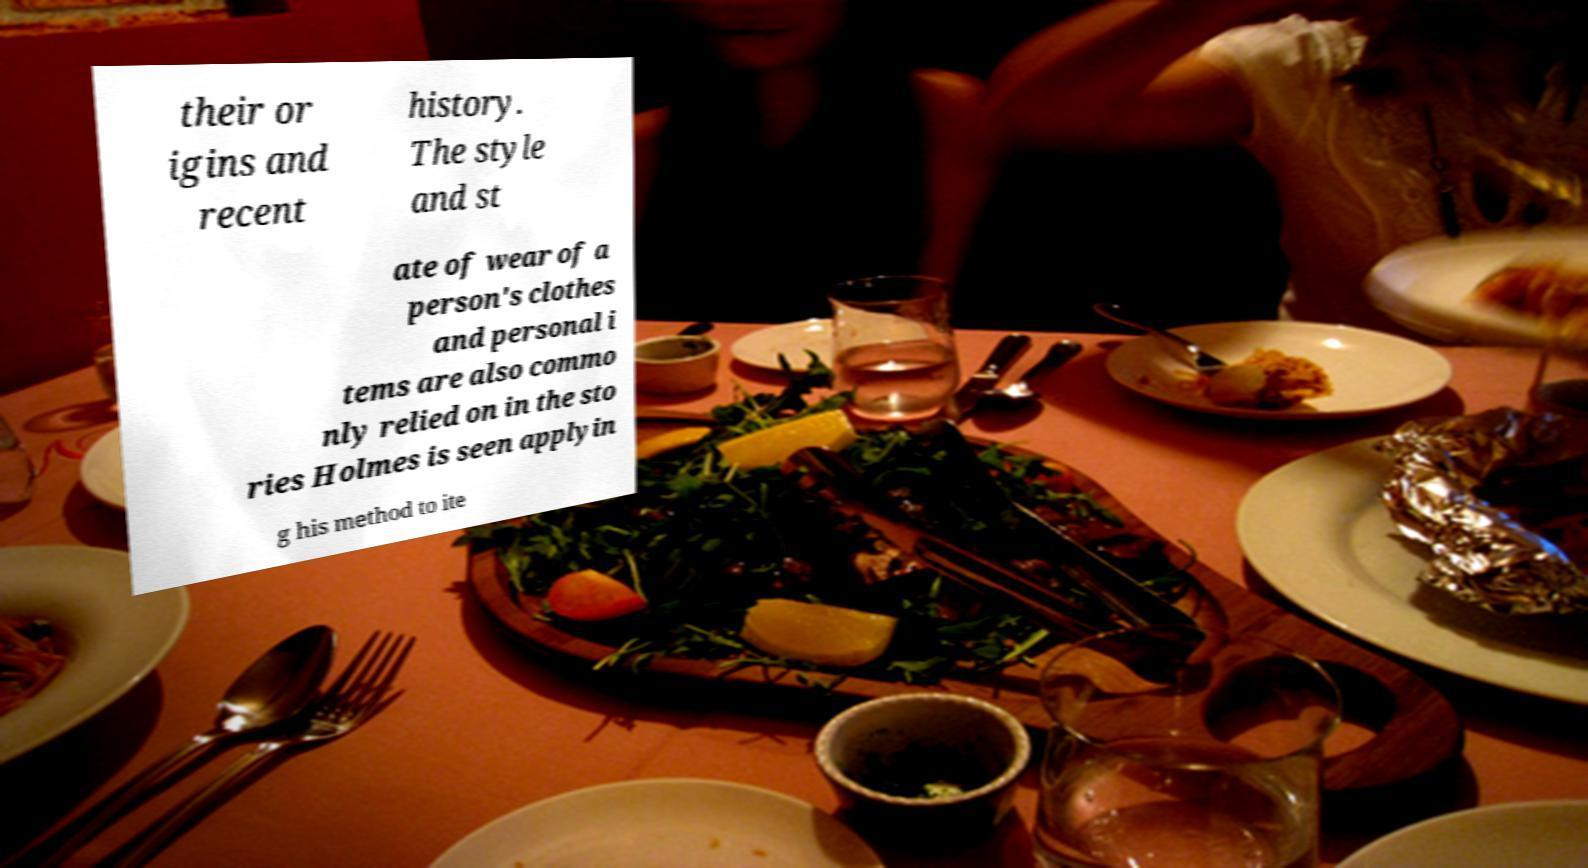Please identify and transcribe the text found in this image. their or igins and recent history. The style and st ate of wear of a person's clothes and personal i tems are also commo nly relied on in the sto ries Holmes is seen applyin g his method to ite 